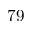<formula> <loc_0><loc_0><loc_500><loc_500>7 9</formula> 